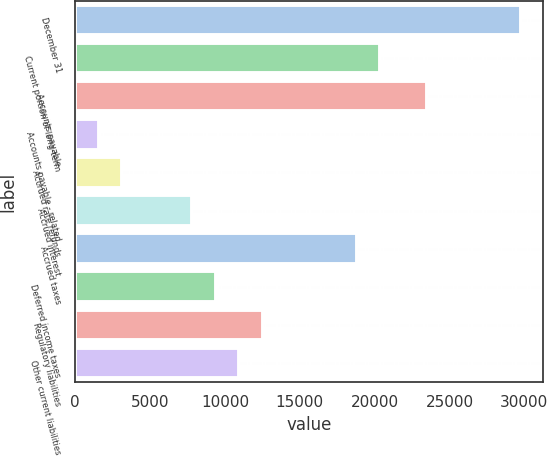Convert chart. <chart><loc_0><loc_0><loc_500><loc_500><bar_chart><fcel>December 31<fcel>Current portion of long-term<fcel>Accounts payable<fcel>Accounts payable - related<fcel>Accrued rate refunds<fcel>Accrued interest<fcel>Accrued taxes<fcel>Deferred income taxes<fcel>Regulatory liabilities<fcel>Other current liabilities<nl><fcel>29756<fcel>20360<fcel>23492<fcel>1568<fcel>3134<fcel>7832<fcel>18794<fcel>9398<fcel>12530<fcel>10964<nl></chart> 